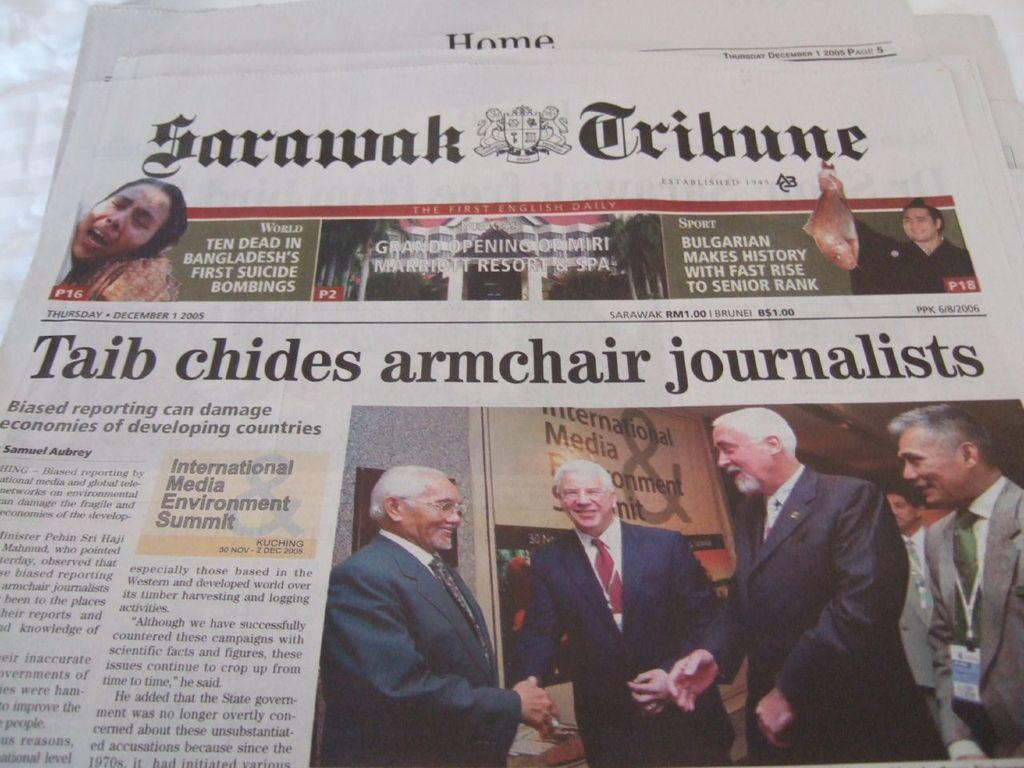What can be seen in the image related to news or current events? There is a newspaper in the image. What specific details can be seen on the newspaper? There is some information visible on the newspaper, and there is a logo on the newspaper. Are there any people present in the image? Yes, there are people in the image. What type of bell can be heard ringing in the image? There is no bell present in the image, and therefore no sound can be heard. 